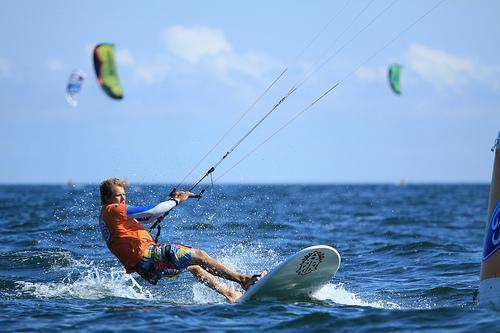How many kites are there?
Give a very brief answer. 3. 